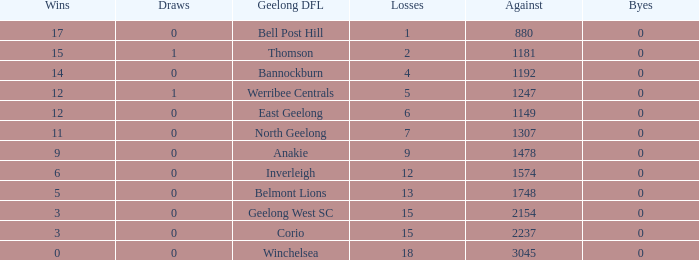What is the lowest number of wins where the losses are more than 12 and the draws are less than 0? None. 